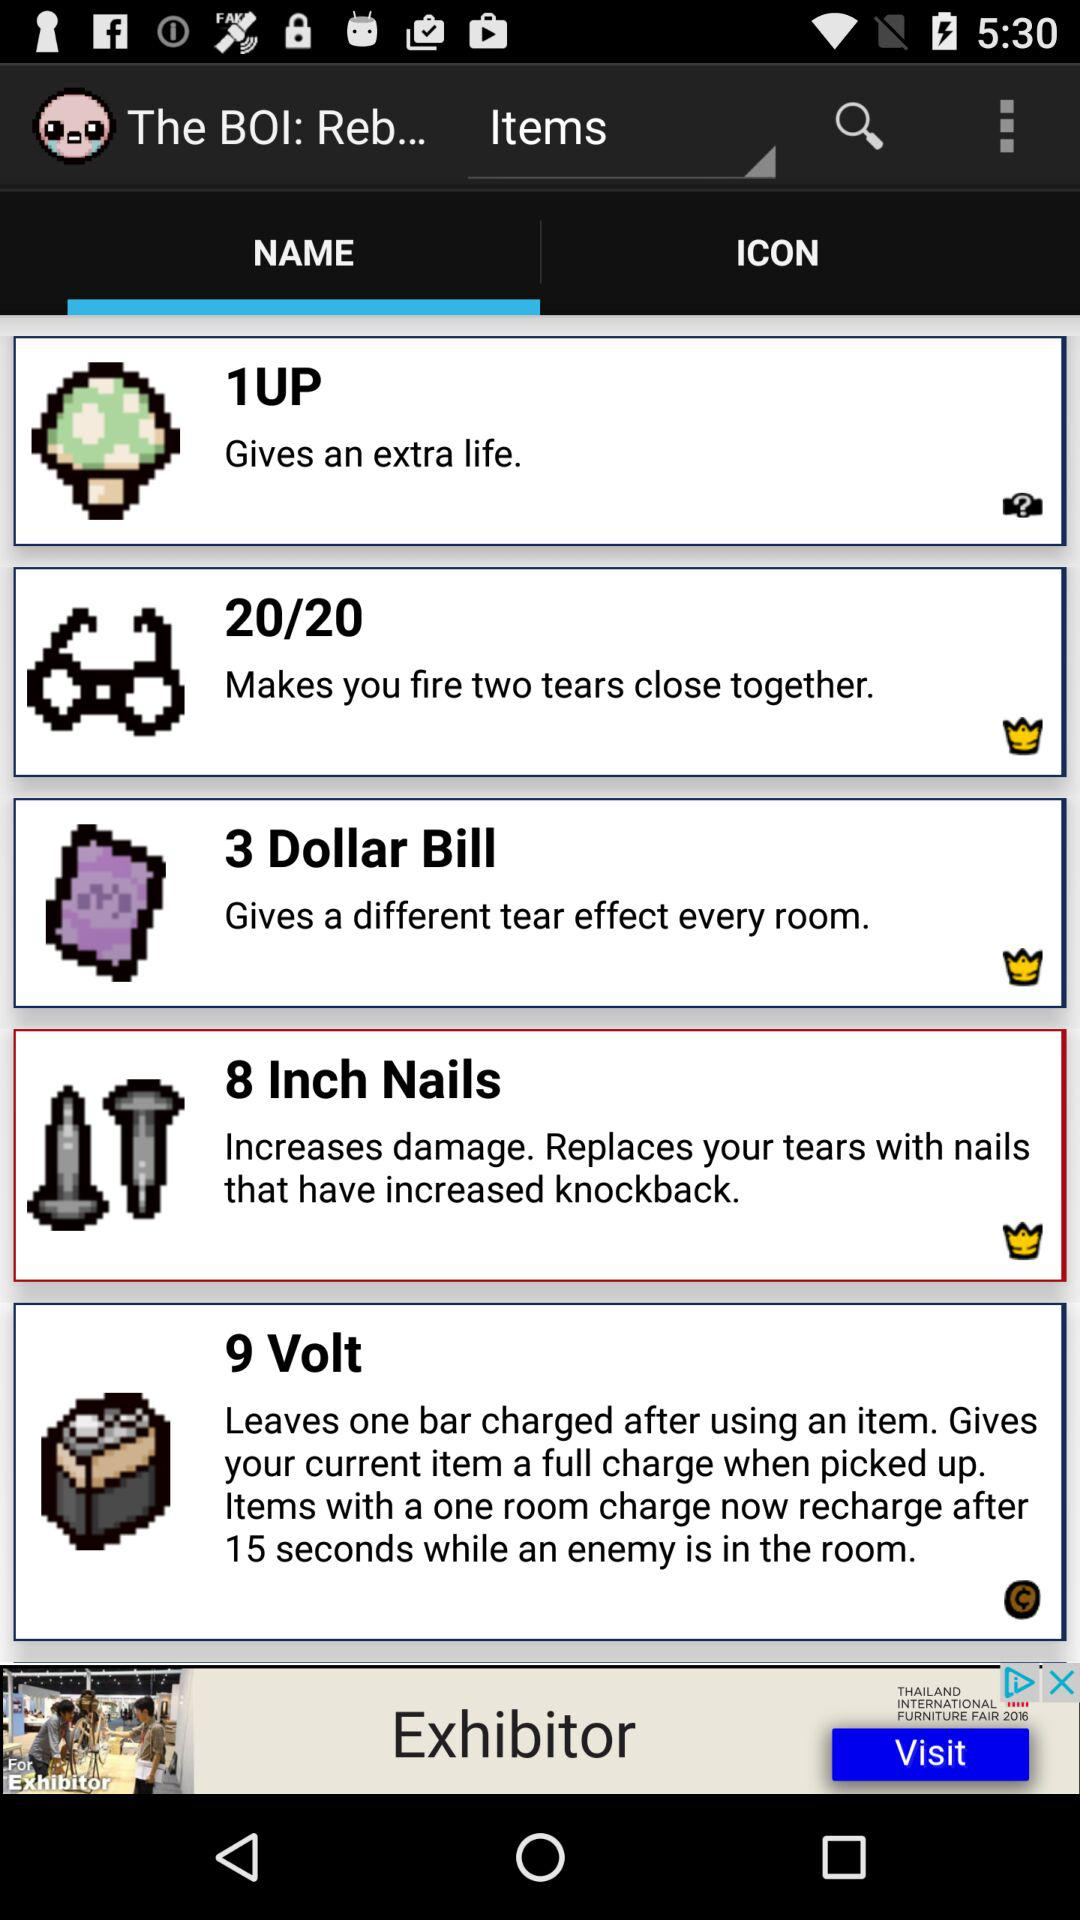Which tab is selected? The selected tab is "NAME". 